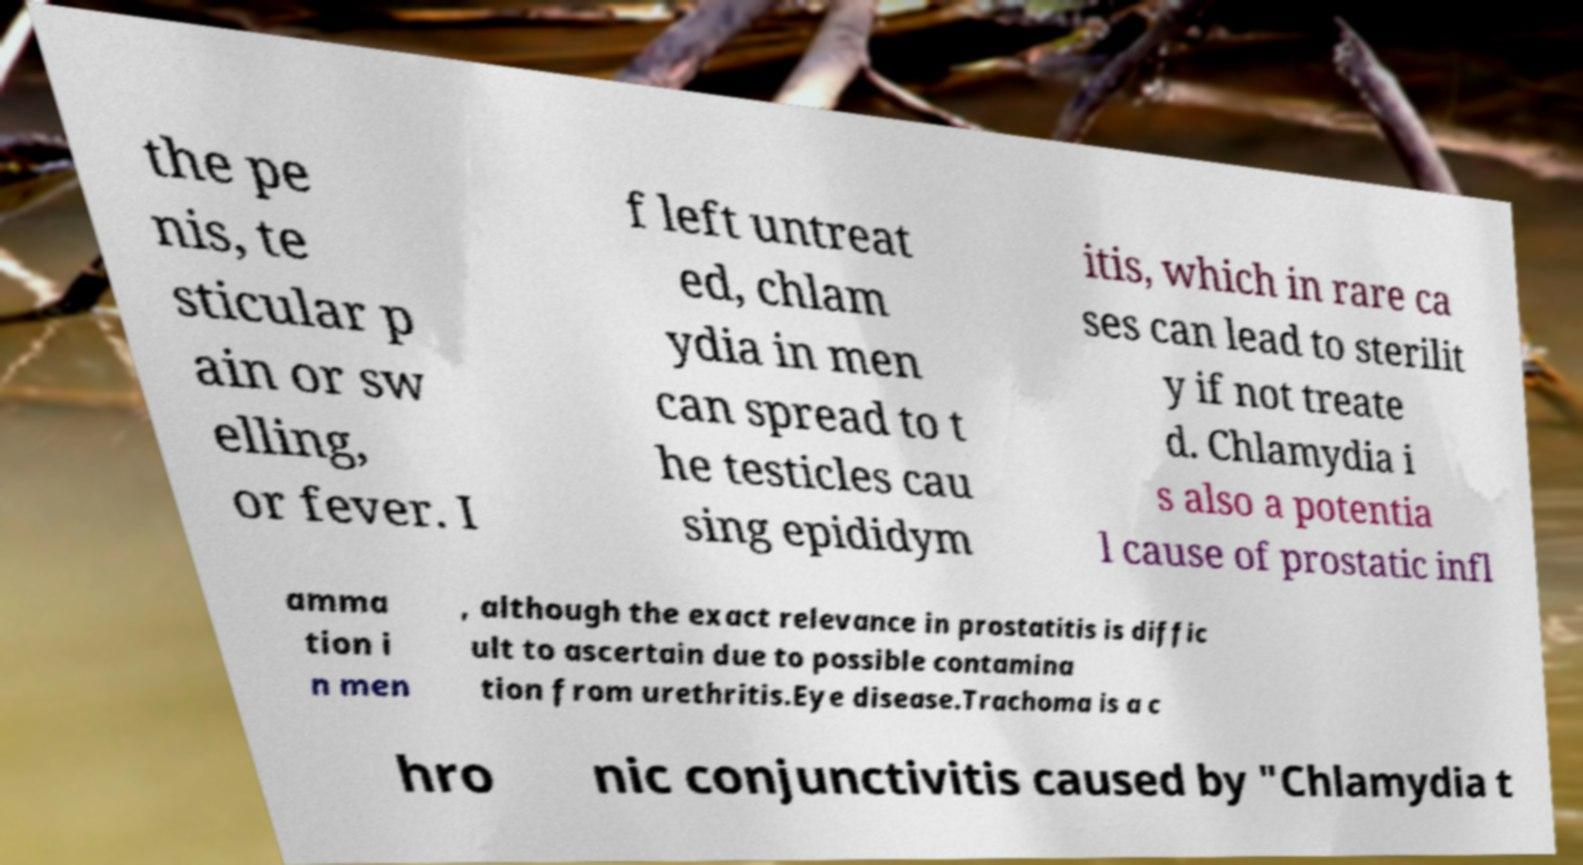Please identify and transcribe the text found in this image. the pe nis, te sticular p ain or sw elling, or fever. I f left untreat ed, chlam ydia in men can spread to t he testicles cau sing epididym itis, which in rare ca ses can lead to sterilit y if not treate d. Chlamydia i s also a potentia l cause of prostatic infl amma tion i n men , although the exact relevance in prostatitis is diffic ult to ascertain due to possible contamina tion from urethritis.Eye disease.Trachoma is a c hro nic conjunctivitis caused by "Chlamydia t 